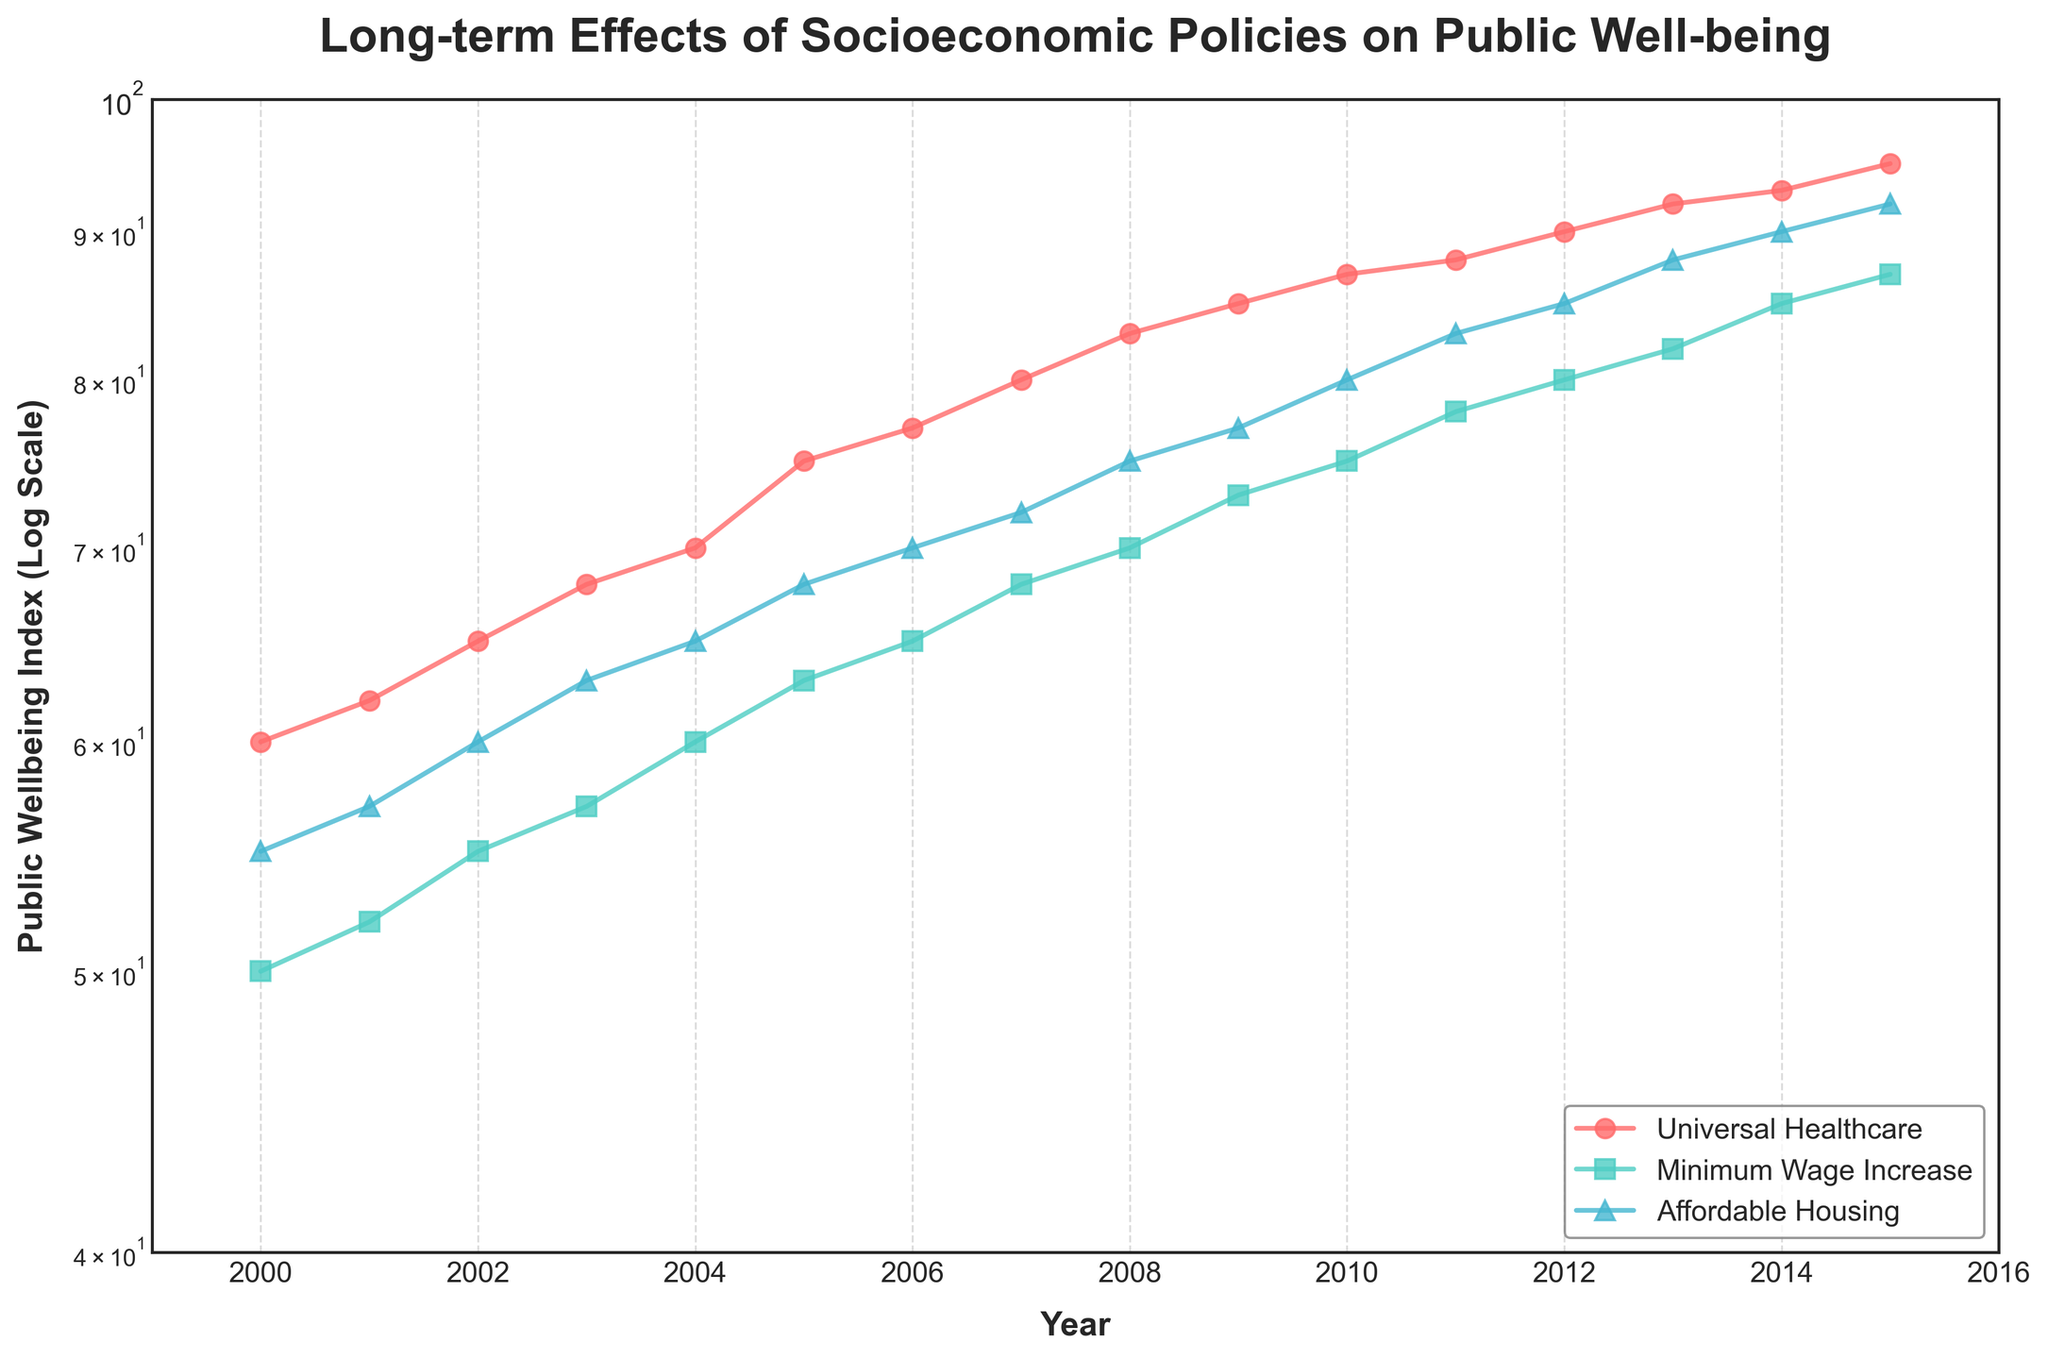What is the title of the figure? The title of the figure is displayed at the top of the plot. In this case, it is "Long-term Effects of Socioeconomic Policies on Public Well-being".
Answer: Long-term Effects of Socioeconomic Policies on Public Well-being What type of scale is used for the y-axis? The y-axis uses a log scale as indicated by the plot labeling and scale formatting.
Answer: Log scale What is the range of years covered by the data in the plot? The x-axis labels show that the data covers from the year 2000 to 2015 inclusively.
Answer: 2000 to 2015 Which socioeconomic policy has the highest Public Wellbeing Index in 2015? By looking at the end points of the lines in 2015, the "Universal Healthcare" policy line ends at the highest Public Wellbeing Index value.
Answer: Universal Healthcare How does the Public Wellbeing Index for Affordable Housing change over time? The trend line for Affordable Housing consistently rises over time from 55 in 2000 to 92 in 2015, showing improvement in Public Wellbeing Index.
Answer: Steadily increases Compare the Public Wellbeing Index for Universal Healthcare and Minimum Wage Increase in 2010. Which is higher and by how much? Universal Healthcare is at 87 and Minimum Wage Increase is at 75. The difference is 87 - 75.
Answer: Universal Healthcare by 12 Which policy had the greatest increase in Public Wellbeing Index from 2000 to 2015? Calculate the difference in Public Wellbeing Index values from 2000 to 2015 for each policy. Universal Healthcare increased from 60 to 95 (+35), Minimum Wage Increase from 50 to 87 (+37), and Affordable Housing from 55 to 92 (+37). Minimum Wage Increase and Affordable Housing both had the greatest increase of 37.
Answer: Minimum Wage Increase and Affordable Housing What is the average Public Wellbeing Index in 2005 across all policies? Sum the Public Wellbeing Index for all policies in 2005, which are 75, 63, and 68, then divide by the number of policies (3). (75 + 63 + 68) / 3 = 68.67
Answer: 68.67 How do the trends of the Public Wellbeing Index for the three policies compare over time? All three policies show an upward trend in the Public Wellbeing Index over time, though the rate of increase and initial values differ across the policies. Universal Healthcare starts higher and ends higher than the others.
Answer: All increase, Universal Healthcare starts and ends higher Are there any years where two or more policies have the same Public Wellbeing Index? By inspecting the lines, there are no exact intersections indicating the same Public Wellbeing Index for different policies in any given year.
Answer: No 